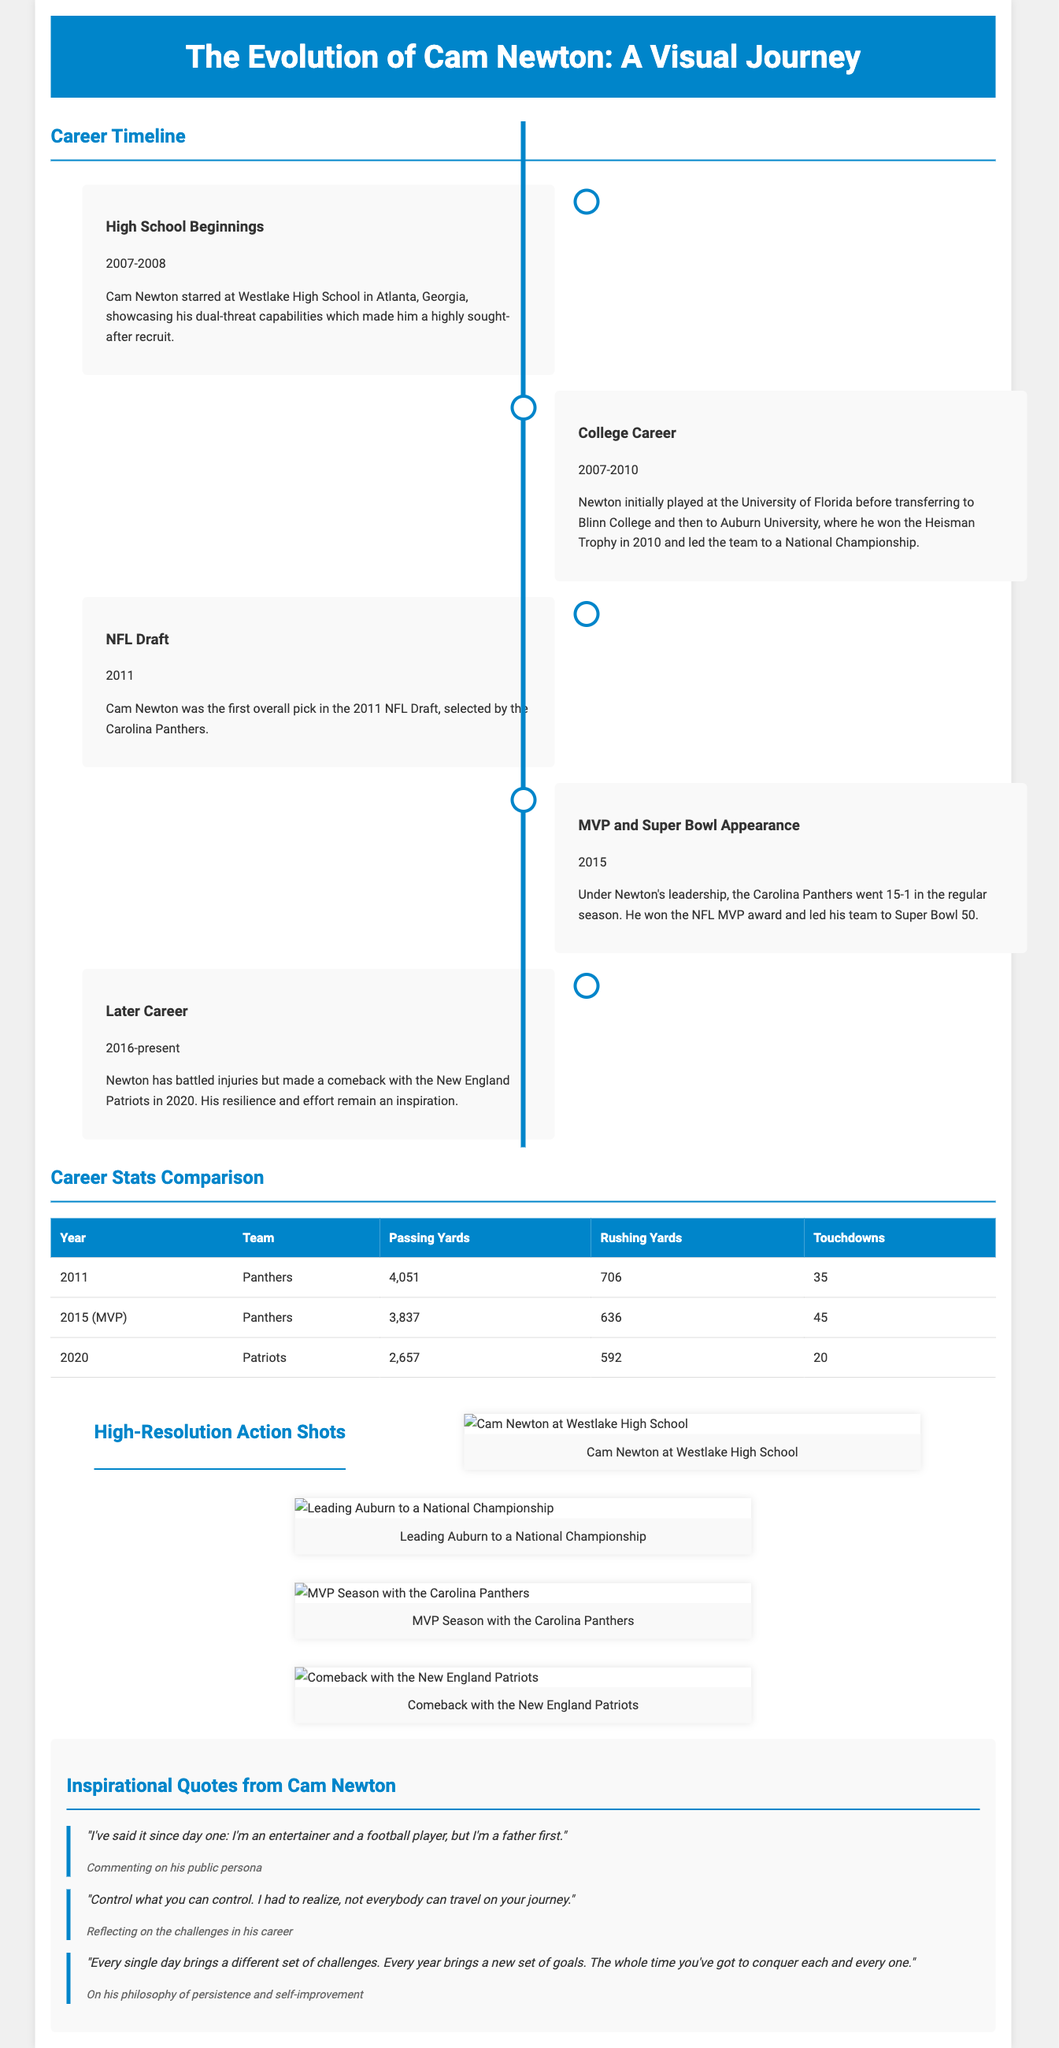What year did Cam Newton win the Heisman Trophy? The document states that Cam Newton won the Heisman Trophy in 2010 during his time at Auburn University.
Answer: 2010 Which team selected Cam Newton in the NFL Draft? The document indicates that Cam Newton was selected by the Carolina Panthers in the 2011 NFL Draft.
Answer: Carolina Panthers How many touchdowns did Cam Newton score in his MVP season? The document mentions that Cam Newton scored 45 touchdowns during the 2015 MVP season.
Answer: 45 What was Cam Newton's passing yards in 2011? The document provides that Cam Newton had 4,051 passing yards in 2011 with the Panthers.
Answer: 4,051 Which college did Cam Newton attend before transferring to Auburn? The document notes that Cam Newton initially played at the University of Florida before transferring.
Answer: University of Florida What was the regular season record for the Panthers in 2015? The document states that the Panthers went 15-1 in the regular season in 2015.
Answer: 15-1 What does Cam Newton emphasize about challenges in his quotes? The document includes a quote where Cam Newton states, "every single day brings a different set of challenges." This highlights his view on the ongoing nature of challenges.
Answer: Ongoing nature of challenges Which visual element features inspiring quotations? The document specifies an entire section titled "Inspirational Quotes from Cam Newton" dedicated to his quotes.
Answer: Inspirational Quotes from Cam Newton What is the primary design element separating timeline entries? The document describes a vertical line as the main design element separating the timeline entries.
Answer: Vertical line 